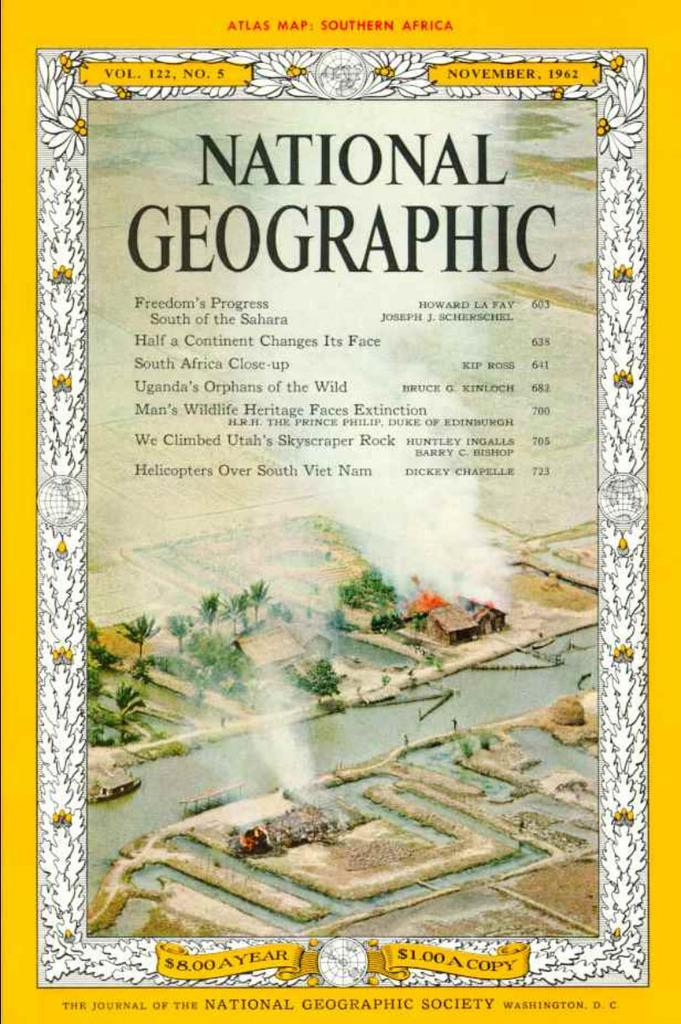Provide a one-sentence caption for the provided image. The cover of a National Geographic magazine from 1962. 